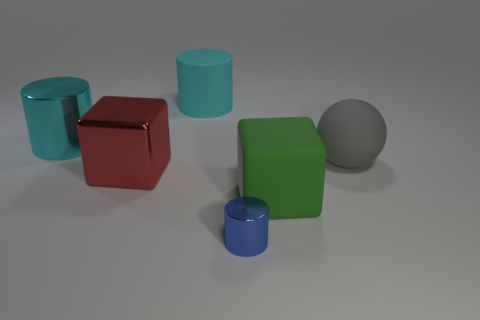Subtract all cyan cylinders. How many cylinders are left? 1 Subtract all purple blocks. How many cyan cylinders are left? 2 Add 3 tiny metallic cubes. How many objects exist? 9 Subtract all cubes. How many objects are left? 4 Subtract 1 cylinders. How many cylinders are left? 2 Add 2 yellow matte spheres. How many yellow matte spheres exist? 2 Subtract 0 gray blocks. How many objects are left? 6 Subtract all brown cylinders. Subtract all yellow spheres. How many cylinders are left? 3 Subtract all gray matte spheres. Subtract all large red metal blocks. How many objects are left? 4 Add 5 blue metal cylinders. How many blue metal cylinders are left? 6 